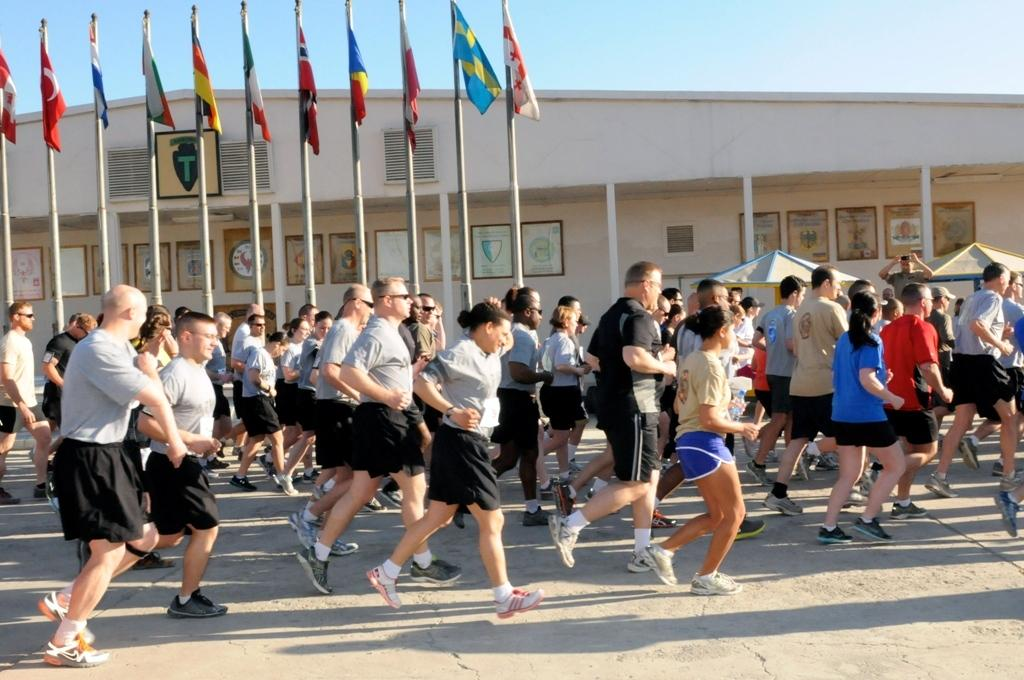What is the main feature of the image? There is a road in the image. What are the people on the road doing? People are running on the road. What can be seen in the background of the image? There are flag poles and a building in the background. What is the color of the sky in the image? The sky is blue in the image. Can you tell me how many waves are visible in the image? There are no waves present in the image; it features a road with people running and a blue sky. What type of picture is being sorted in the image? There is no picture or sorting activity depicted in the image. 